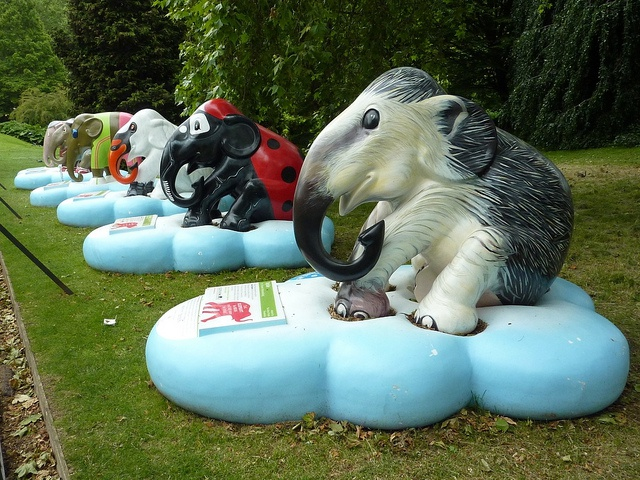Describe the objects in this image and their specific colors. I can see elephant in darkgreen, black, darkgray, gray, and lightgray tones, elephant in darkgreen, black, brown, maroon, and gray tones, elephant in darkgreen, lightgray, darkgray, lightblue, and black tones, book in darkgreen, white, lightblue, lightgreen, and lightpink tones, and elephant in darkgreen, gray, and olive tones in this image. 